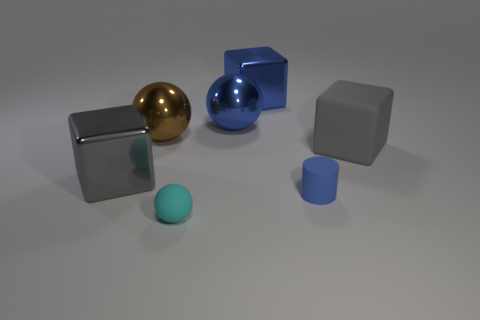Add 3 tiny blue things. How many objects exist? 10 Subtract all spheres. How many objects are left? 4 Subtract all big blue blocks. Subtract all large gray shiny objects. How many objects are left? 5 Add 1 big gray rubber things. How many big gray rubber things are left? 2 Add 2 big purple blocks. How many big purple blocks exist? 2 Subtract 0 brown cylinders. How many objects are left? 7 